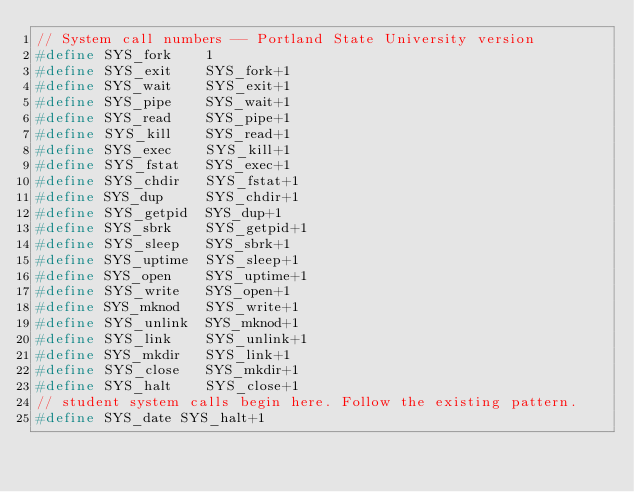<code> <loc_0><loc_0><loc_500><loc_500><_C_>// System call numbers -- Portland State University version
#define SYS_fork    1
#define SYS_exit    SYS_fork+1
#define SYS_wait    SYS_exit+1
#define SYS_pipe    SYS_wait+1
#define SYS_read    SYS_pipe+1
#define SYS_kill    SYS_read+1
#define SYS_exec    SYS_kill+1
#define SYS_fstat   SYS_exec+1
#define SYS_chdir   SYS_fstat+1
#define SYS_dup     SYS_chdir+1
#define SYS_getpid  SYS_dup+1
#define SYS_sbrk    SYS_getpid+1
#define SYS_sleep   SYS_sbrk+1
#define SYS_uptime  SYS_sleep+1
#define SYS_open    SYS_uptime+1
#define SYS_write   SYS_open+1
#define SYS_mknod   SYS_write+1
#define SYS_unlink  SYS_mknod+1
#define SYS_link    SYS_unlink+1
#define SYS_mkdir   SYS_link+1
#define SYS_close   SYS_mkdir+1
#define SYS_halt    SYS_close+1
// student system calls begin here. Follow the existing pattern.
#define SYS_date SYS_halt+1
</code> 